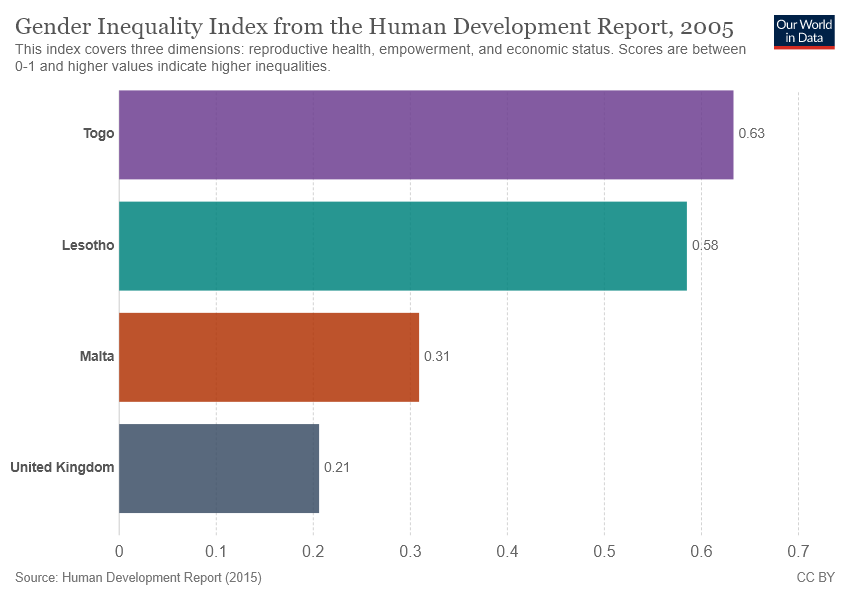Specify some key components in this picture. The smallest two bars combined equal 0.52. The value of Malta is 0.31. 